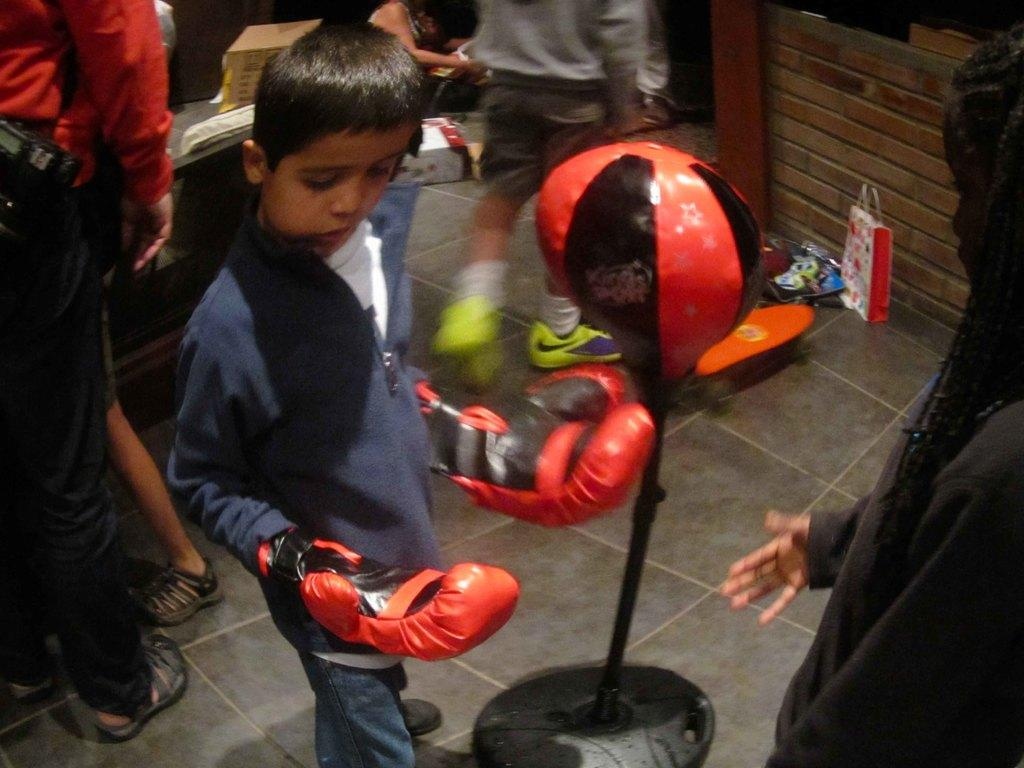Who is the main subject in the image? There is a boy in the center of the image. What is the boy wearing on his hands? The boy is wearing boxing gloves. What can be seen in the background of the image? There are persons visible in the background, and there is a wall in the background. What type of wax is being used to polish the linen in the image? There is no wax or linen present in the image; it features a boy wearing boxing gloves and a background with other persons and a wall. 